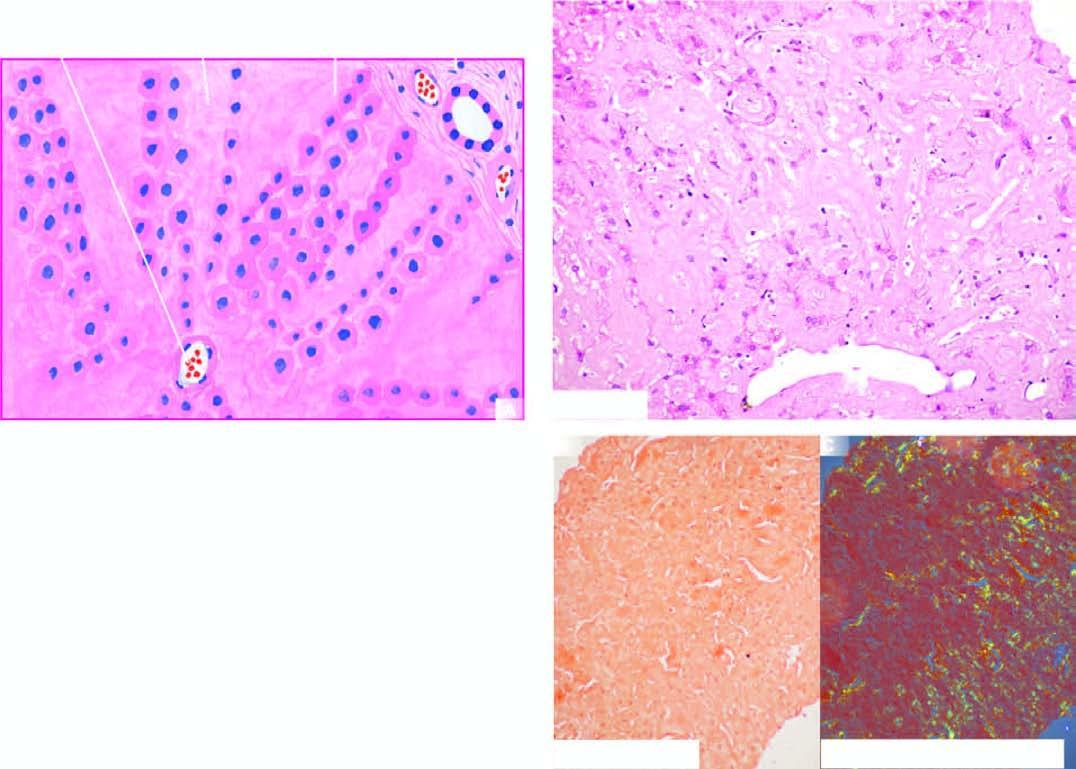does strands show apple-green birefringence?
Answer the question using a single word or phrase. No 